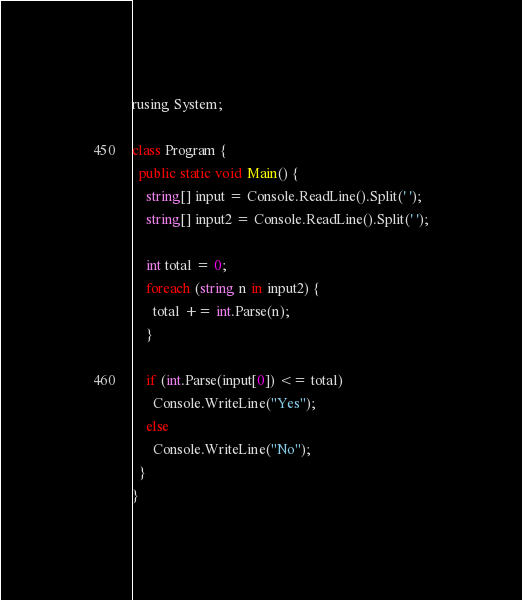Convert code to text. <code><loc_0><loc_0><loc_500><loc_500><_C#_>rusing System;

class Program {
  public static void Main() {
    string[] input = Console.ReadLine().Split(' ');
    string[] input2 = Console.ReadLine().Split(' ');
    
    int total = 0;
    foreach (string n in input2) {
      total += int.Parse(n);
    }

    if (int.Parse(input[0]) <= total)
      Console.WriteLine("Yes");
    else
      Console.WriteLine("No");
  }
}
</code> 